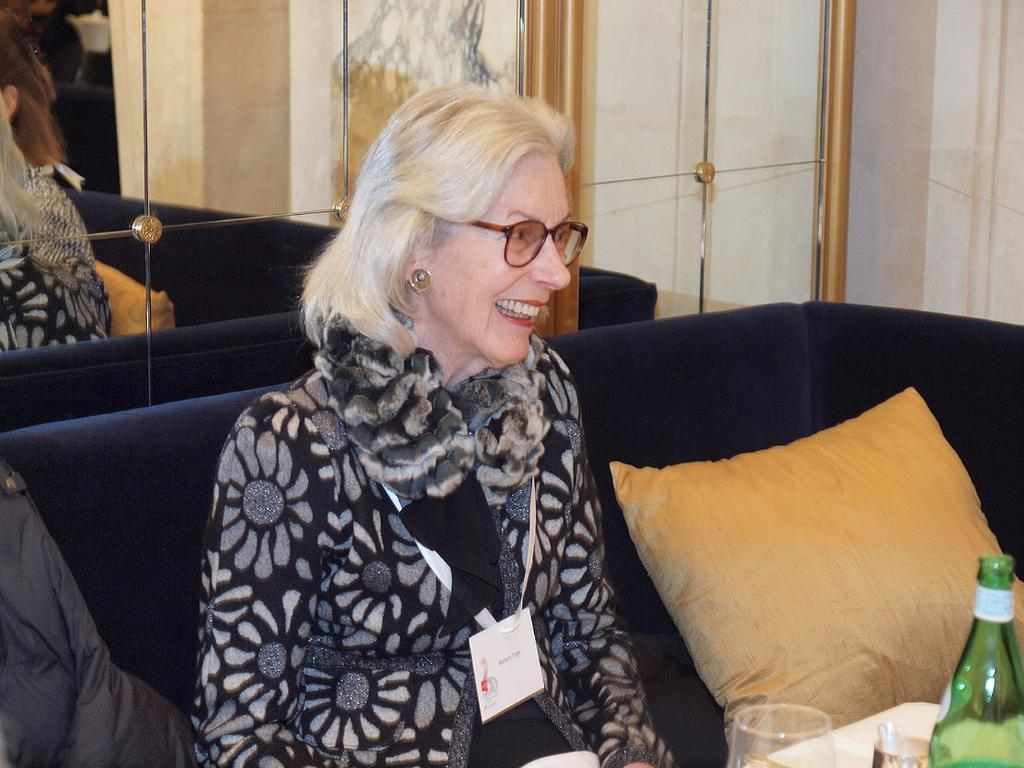Who is present in the image? There is a woman in the image. What is the woman wearing that helps her see better? The woman is wearing spectacles. What type of identification does the woman have? The woman has an ID card. Where is the woman sitting in the image? The woman is sitting on a sofa. What items are in front of the woman? There is a bottle, a glass, and a pillow in front of the woman. What can be seen in the background of the image? There is a mirror in the background of the image. What type of queen is depicted in the image? There is no queen depicted in the image; it features a woman sitting on a sofa. How does the woman burn the items in front of her? The woman does not burn any items in the image; there is a bottle, a glass, and a pillow in front of her. 